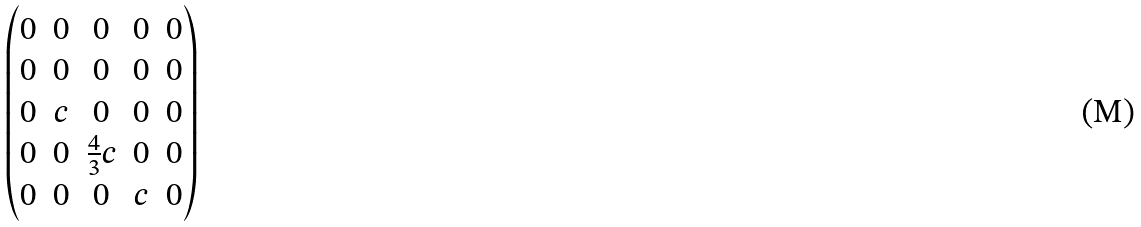<formula> <loc_0><loc_0><loc_500><loc_500>\begin{pmatrix} 0 & 0 & 0 & 0 & 0 \\ 0 & 0 & 0 & 0 & 0 \\ 0 & c & 0 & 0 & 0 \\ 0 & 0 & \frac { 4 } { 3 } c & 0 & 0 \\ 0 & 0 & 0 & c & 0 \end{pmatrix}</formula> 